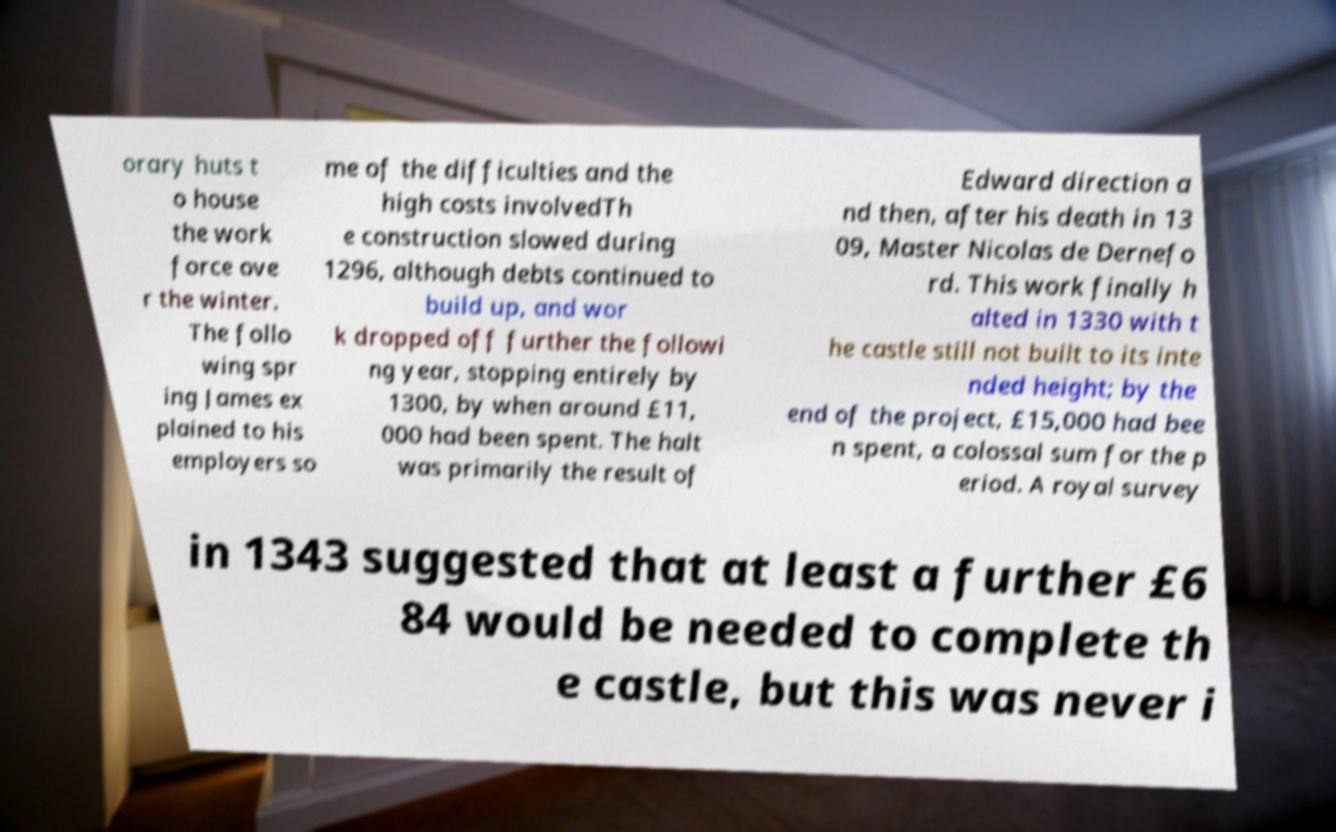Could you extract and type out the text from this image? orary huts t o house the work force ove r the winter. The follo wing spr ing James ex plained to his employers so me of the difficulties and the high costs involvedTh e construction slowed during 1296, although debts continued to build up, and wor k dropped off further the followi ng year, stopping entirely by 1300, by when around £11, 000 had been spent. The halt was primarily the result of Edward direction a nd then, after his death in 13 09, Master Nicolas de Dernefo rd. This work finally h alted in 1330 with t he castle still not built to its inte nded height; by the end of the project, £15,000 had bee n spent, a colossal sum for the p eriod. A royal survey in 1343 suggested that at least a further £6 84 would be needed to complete th e castle, but this was never i 